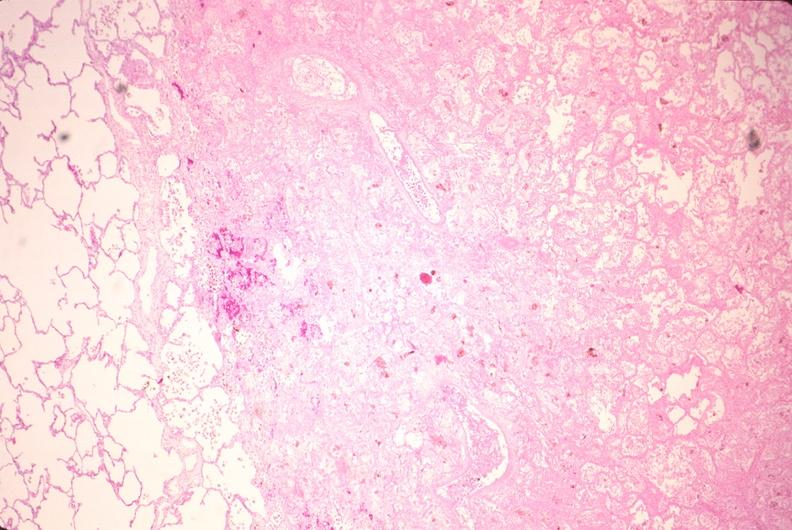s respiratory present?
Answer the question using a single word or phrase. Yes 